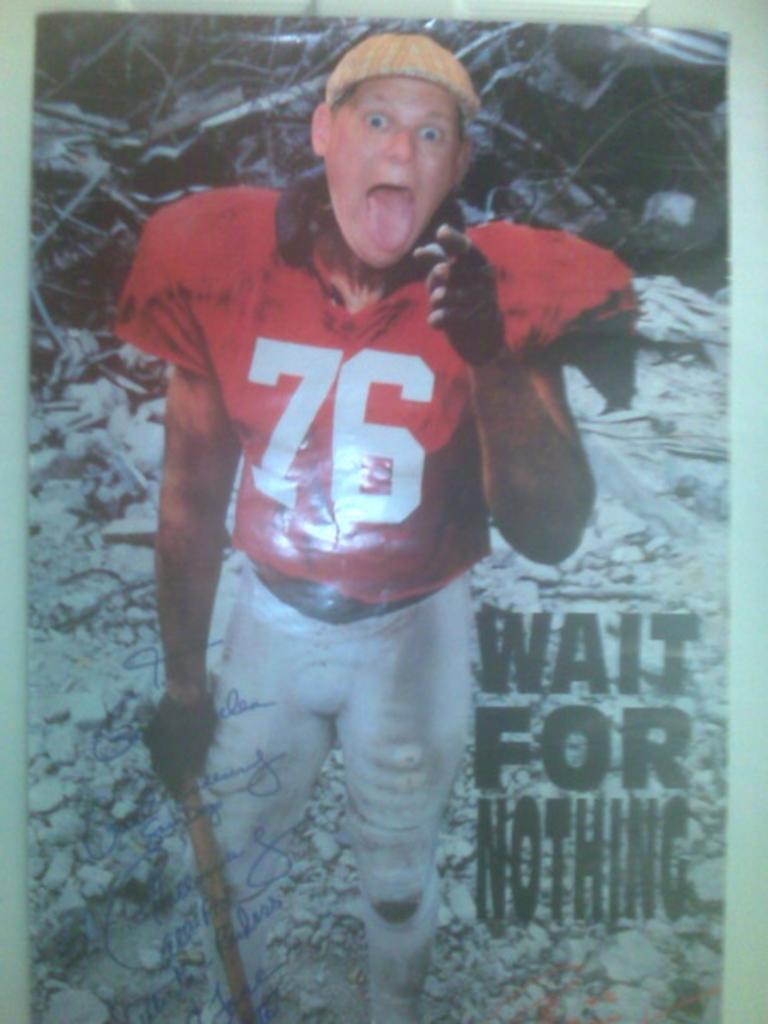What should you wait for according to the picture?
Keep it short and to the point. Nothing. What is the number featured on the jersey?
Ensure brevity in your answer.  76. 